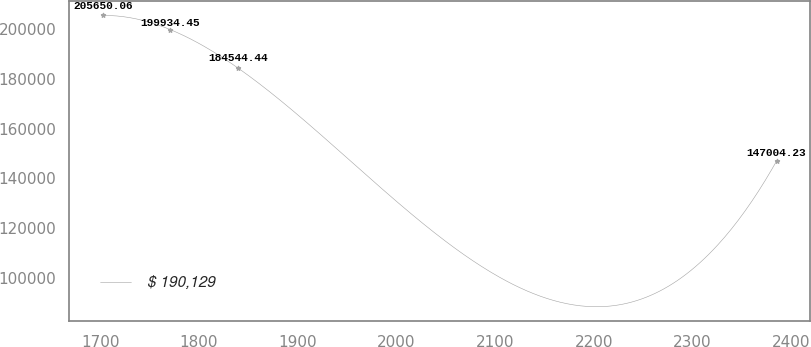<chart> <loc_0><loc_0><loc_500><loc_500><line_chart><ecel><fcel>$ 190,129<nl><fcel>1702.82<fcel>205650<nl><fcel>1771.04<fcel>199934<nl><fcel>1839.26<fcel>184544<nl><fcel>2384.99<fcel>147004<nl></chart> 